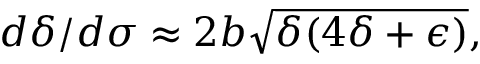Convert formula to latex. <formula><loc_0><loc_0><loc_500><loc_500>d \delta / d \sigma \approx 2 b \sqrt { \delta ( 4 \delta + \epsilon ) } ,</formula> 